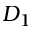Convert formula to latex. <formula><loc_0><loc_0><loc_500><loc_500>D _ { 1 }</formula> 